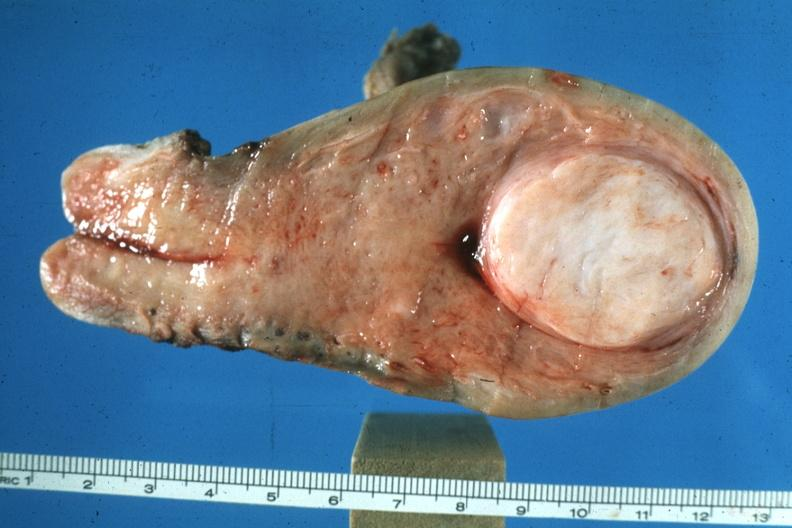does this image show excellent example of rather large submucous myoma?
Answer the question using a single word or phrase. Yes 